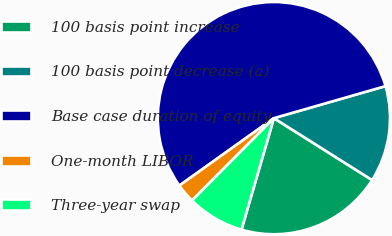Convert chart. <chart><loc_0><loc_0><loc_500><loc_500><pie_chart><fcel>100 basis point increase<fcel>100 basis point decrease (a)<fcel>Base case duration of equity<fcel>One-month LIBOR<fcel>Three-year swap<nl><fcel>20.55%<fcel>13.4%<fcel>55.41%<fcel>2.68%<fcel>7.95%<nl></chart> 